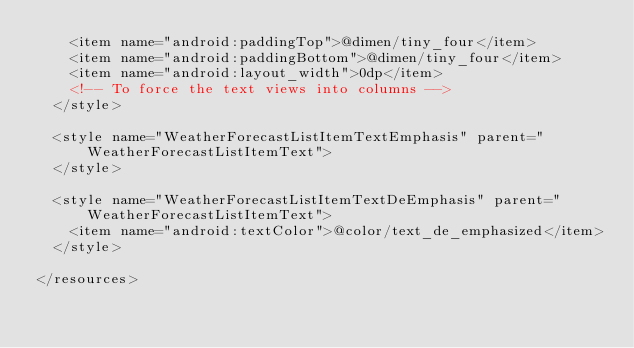Convert code to text. <code><loc_0><loc_0><loc_500><loc_500><_XML_>    <item name="android:paddingTop">@dimen/tiny_four</item>
    <item name="android:paddingBottom">@dimen/tiny_four</item>
    <item name="android:layout_width">0dp</item>
    <!-- To force the text views into columns -->
  </style>

  <style name="WeatherForecastListItemTextEmphasis" parent="WeatherForecastListItemText">
  </style>

  <style name="WeatherForecastListItemTextDeEmphasis" parent="WeatherForecastListItemText">
    <item name="android:textColor">@color/text_de_emphasized</item>
  </style>

</resources>
</code> 